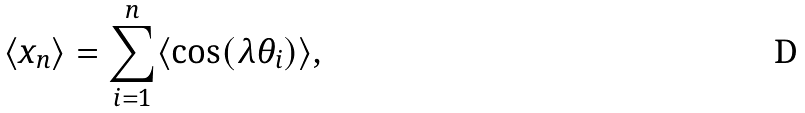<formula> <loc_0><loc_0><loc_500><loc_500>\langle x _ { n } \rangle = \sum _ { i = 1 } ^ { n } \langle \cos ( \lambda \theta _ { i } ) \rangle ,</formula> 